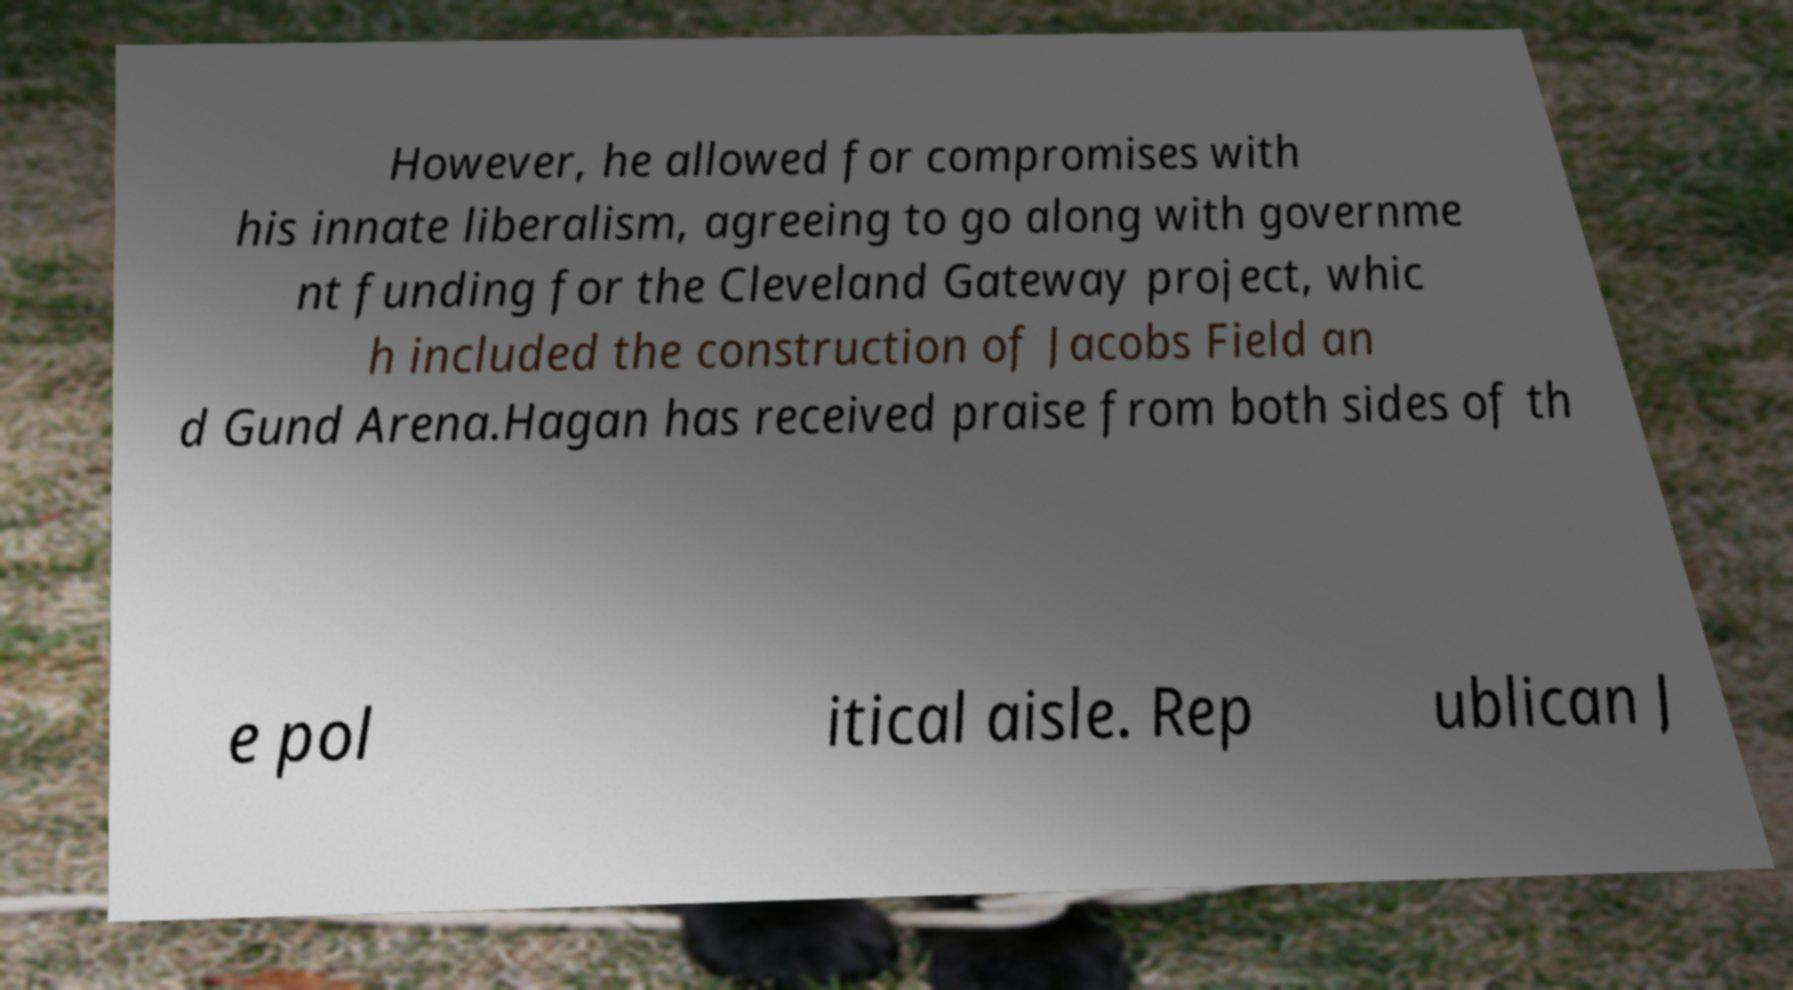I need the written content from this picture converted into text. Can you do that? However, he allowed for compromises with his innate liberalism, agreeing to go along with governme nt funding for the Cleveland Gateway project, whic h included the construction of Jacobs Field an d Gund Arena.Hagan has received praise from both sides of th e pol itical aisle. Rep ublican J 